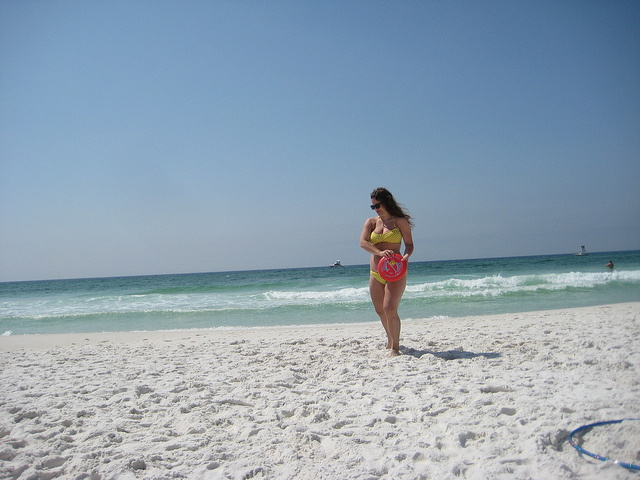What activities aside from walking are noticeable on the beach? Apart from the person walking, the beach seems relatively tranquil. There's no clear evidence of other activities happening on the sand, although there's a blue object near the water's edge that could be a beach item like a frisbee or a toy. 